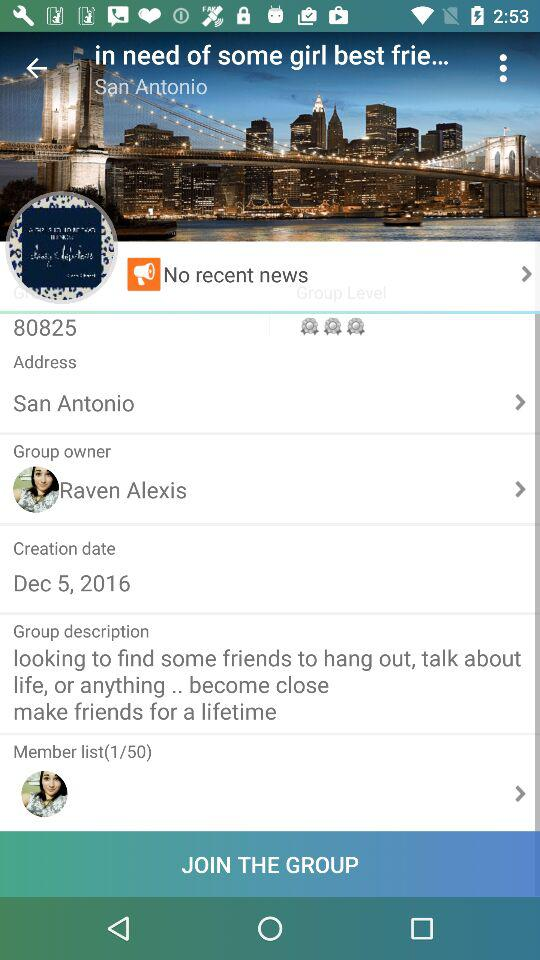What is the total count of the member list? The total count is 50. 